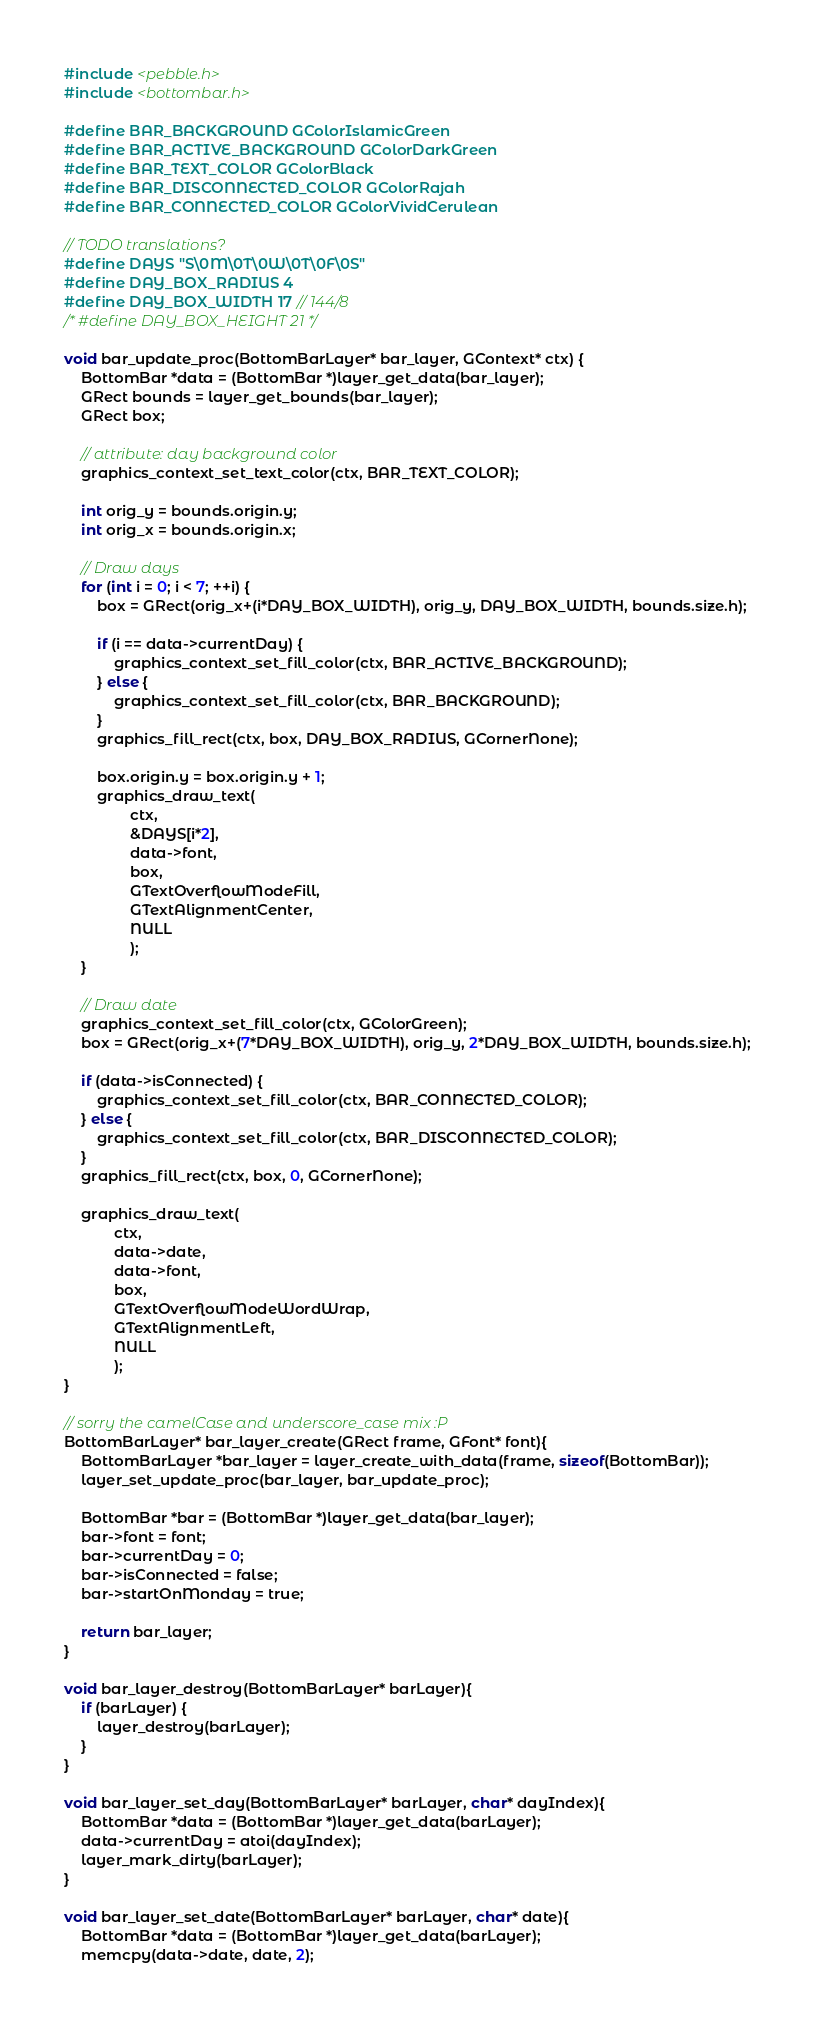<code> <loc_0><loc_0><loc_500><loc_500><_C_>#include <pebble.h>
#include <bottombar.h>

#define BAR_BACKGROUND GColorIslamicGreen
#define BAR_ACTIVE_BACKGROUND GColorDarkGreen
#define BAR_TEXT_COLOR GColorBlack
#define BAR_DISCONNECTED_COLOR GColorRajah
#define BAR_CONNECTED_COLOR GColorVividCerulean

// TODO translations?
#define DAYS "S\0M\0T\0W\0T\0F\0S"
#define DAY_BOX_RADIUS 4
#define DAY_BOX_WIDTH 17 // 144/8
/* #define DAY_BOX_HEIGHT 21 */

void bar_update_proc(BottomBarLayer* bar_layer, GContext* ctx) {
    BottomBar *data = (BottomBar *)layer_get_data(bar_layer);
    GRect bounds = layer_get_bounds(bar_layer);
    GRect box;

    // attribute: day background color
    graphics_context_set_text_color(ctx, BAR_TEXT_COLOR);

    int orig_y = bounds.origin.y;
    int orig_x = bounds.origin.x;

    // Draw days
    for (int i = 0; i < 7; ++i) {
        box = GRect(orig_x+(i*DAY_BOX_WIDTH), orig_y, DAY_BOX_WIDTH, bounds.size.h);

        if (i == data->currentDay) {
            graphics_context_set_fill_color(ctx, BAR_ACTIVE_BACKGROUND);
        } else {
            graphics_context_set_fill_color(ctx, BAR_BACKGROUND);
        }
        graphics_fill_rect(ctx, box, DAY_BOX_RADIUS, GCornerNone);

        box.origin.y = box.origin.y + 1;
        graphics_draw_text(
                ctx,
                &DAYS[i*2],
                data->font,
                box,
                GTextOverflowModeFill,
                GTextAlignmentCenter,
                NULL
                );
    }

    // Draw date
    graphics_context_set_fill_color(ctx, GColorGreen);
    box = GRect(orig_x+(7*DAY_BOX_WIDTH), orig_y, 2*DAY_BOX_WIDTH, bounds.size.h);

    if (data->isConnected) {
        graphics_context_set_fill_color(ctx, BAR_CONNECTED_COLOR);
    } else {
        graphics_context_set_fill_color(ctx, BAR_DISCONNECTED_COLOR);
    }
    graphics_fill_rect(ctx, box, 0, GCornerNone);

    graphics_draw_text(
            ctx,
            data->date,
            data->font,
            box,
            GTextOverflowModeWordWrap,
            GTextAlignmentLeft,
            NULL
            );
}

// sorry the camelCase and underscore_case mix :P
BottomBarLayer* bar_layer_create(GRect frame, GFont* font){
    BottomBarLayer *bar_layer = layer_create_with_data(frame, sizeof(BottomBar));
    layer_set_update_proc(bar_layer, bar_update_proc);

    BottomBar *bar = (BottomBar *)layer_get_data(bar_layer);
    bar->font = font;
    bar->currentDay = 0;
    bar->isConnected = false;
    bar->startOnMonday = true;

    return bar_layer;
}

void bar_layer_destroy(BottomBarLayer* barLayer){
    if (barLayer) {
        layer_destroy(barLayer);
    }
}

void bar_layer_set_day(BottomBarLayer* barLayer, char* dayIndex){
    BottomBar *data = (BottomBar *)layer_get_data(barLayer);
    data->currentDay = atoi(dayIndex);
    layer_mark_dirty(barLayer);
}

void bar_layer_set_date(BottomBarLayer* barLayer, char* date){
    BottomBar *data = (BottomBar *)layer_get_data(barLayer);
    memcpy(data->date, date, 2);</code> 